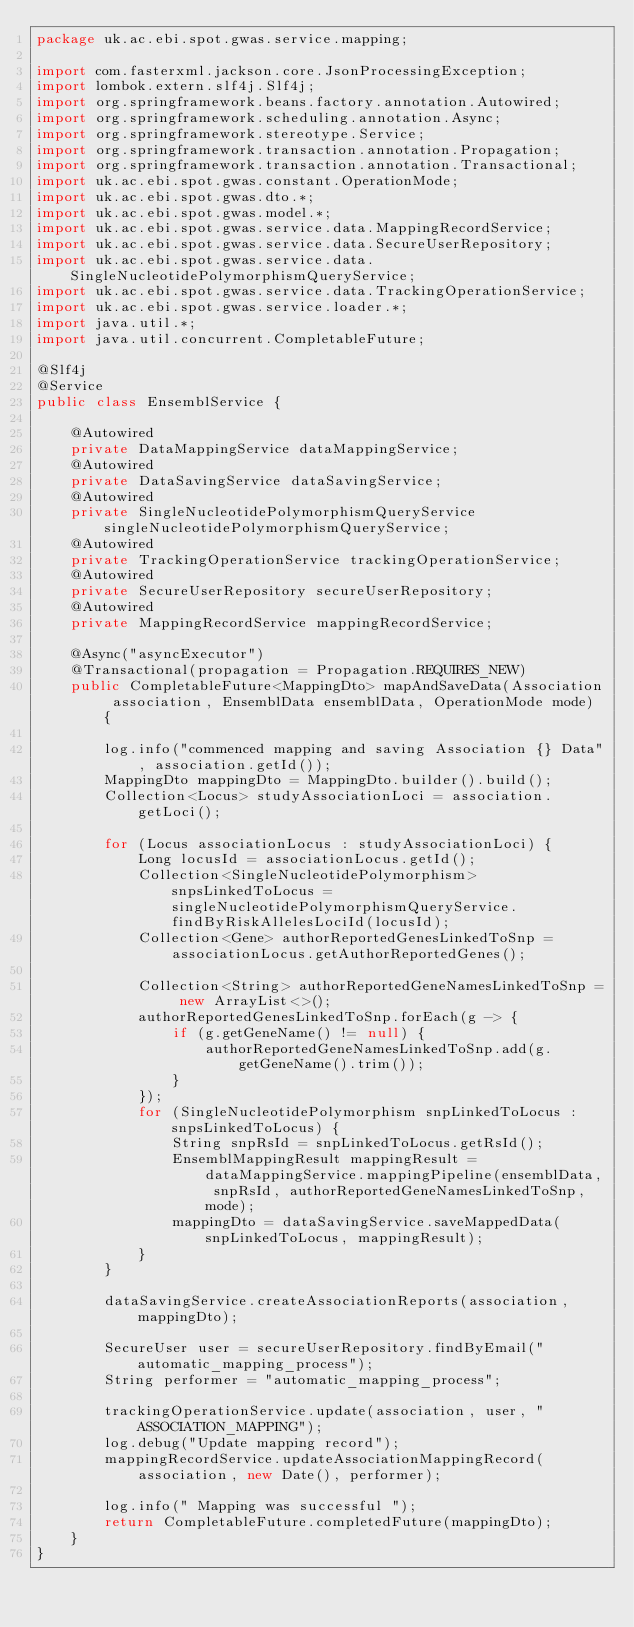<code> <loc_0><loc_0><loc_500><loc_500><_Java_>package uk.ac.ebi.spot.gwas.service.mapping;

import com.fasterxml.jackson.core.JsonProcessingException;
import lombok.extern.slf4j.Slf4j;
import org.springframework.beans.factory.annotation.Autowired;
import org.springframework.scheduling.annotation.Async;
import org.springframework.stereotype.Service;
import org.springframework.transaction.annotation.Propagation;
import org.springframework.transaction.annotation.Transactional;
import uk.ac.ebi.spot.gwas.constant.OperationMode;
import uk.ac.ebi.spot.gwas.dto.*;
import uk.ac.ebi.spot.gwas.model.*;
import uk.ac.ebi.spot.gwas.service.data.MappingRecordService;
import uk.ac.ebi.spot.gwas.service.data.SecureUserRepository;
import uk.ac.ebi.spot.gwas.service.data.SingleNucleotidePolymorphismQueryService;
import uk.ac.ebi.spot.gwas.service.data.TrackingOperationService;
import uk.ac.ebi.spot.gwas.service.loader.*;
import java.util.*;
import java.util.concurrent.CompletableFuture;

@Slf4j
@Service
public class EnsemblService {

    @Autowired
    private DataMappingService dataMappingService;
    @Autowired
    private DataSavingService dataSavingService;
    @Autowired
    private SingleNucleotidePolymorphismQueryService singleNucleotidePolymorphismQueryService;
    @Autowired
    private TrackingOperationService trackingOperationService;
    @Autowired
    private SecureUserRepository secureUserRepository;
    @Autowired
    private MappingRecordService mappingRecordService;

    @Async("asyncExecutor")
    @Transactional(propagation = Propagation.REQUIRES_NEW)
    public CompletableFuture<MappingDto> mapAndSaveData(Association association, EnsemblData ensemblData, OperationMode mode) {

        log.info("commenced mapping and saving Association {} Data", association.getId());
        MappingDto mappingDto = MappingDto.builder().build();
        Collection<Locus> studyAssociationLoci = association.getLoci();

        for (Locus associationLocus : studyAssociationLoci) {
            Long locusId = associationLocus.getId();
            Collection<SingleNucleotidePolymorphism> snpsLinkedToLocus = singleNucleotidePolymorphismQueryService.findByRiskAllelesLociId(locusId);
            Collection<Gene> authorReportedGenesLinkedToSnp = associationLocus.getAuthorReportedGenes();

            Collection<String> authorReportedGeneNamesLinkedToSnp = new ArrayList<>();
            authorReportedGenesLinkedToSnp.forEach(g -> {
                if (g.getGeneName() != null) {
                    authorReportedGeneNamesLinkedToSnp.add(g.getGeneName().trim());
                }
            });
            for (SingleNucleotidePolymorphism snpLinkedToLocus : snpsLinkedToLocus) {
                String snpRsId = snpLinkedToLocus.getRsId();
                EnsemblMappingResult mappingResult = dataMappingService.mappingPipeline(ensemblData, snpRsId, authorReportedGeneNamesLinkedToSnp, mode);
                mappingDto = dataSavingService.saveMappedData(snpLinkedToLocus, mappingResult);
            }
        }

        dataSavingService.createAssociationReports(association, mappingDto);

        SecureUser user = secureUserRepository.findByEmail("automatic_mapping_process");
        String performer = "automatic_mapping_process";

        trackingOperationService.update(association, user, "ASSOCIATION_MAPPING");
        log.debug("Update mapping record");
        mappingRecordService.updateAssociationMappingRecord(association, new Date(), performer);

        log.info(" Mapping was successful ");
        return CompletableFuture.completedFuture(mappingDto);
    }
}
</code> 